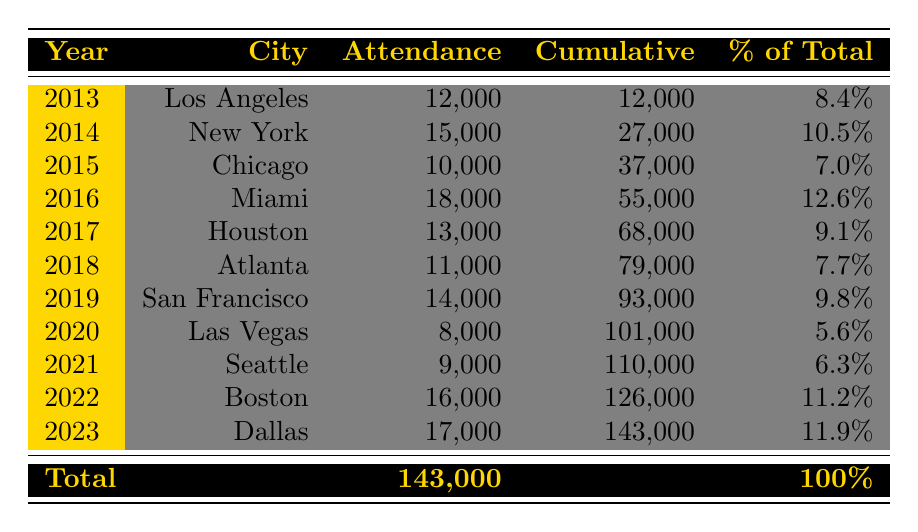What was the attendance at the Miami concert in 2016? The table shows that in 2016, the attendance in Miami was 18,000. This information can be found directly in the table under the Year 2016 and City Miami.
Answer: 18,000 Which city had the highest concert attendance and what was that number? By examining the attendance figures, Miami in 2016 has the highest attendance at 18,000, which is the maximum value compared to others in the table.
Answer: Miami, 18,000 What is the cumulative attendance by the end of 2021? To find the cumulative attendance by the end of 2021, we sum up the attendance values from 2013 to 2021: 12,000 + 15,000 + 10,000 + 18,000 + 13,000 + 11,000 + 14,000 + 8,000 + 9,000 = 110,000. The cumulative value is listed in the table for 2021 under ‘Cumulative’.
Answer: 110,000 Is the percentage of total attendance for Los Angeles in 2013 greater than 10%? Referring to the table, Los Angeles in 2013 has an attendance of 12,000. The total attendance is 143,000, and the percentage for Los Angeles is calculated as (12,000 / 143,000) * 100, which is approximately 8.4%. Since 8.4% is not greater than 10%, the answer is no.
Answer: No What was the difference in attendance between the concerts in Dallas and Chicago? From the table, the attendance in Dallas in 2023 is 17,000 and in Chicago in 2015 is 10,000. To find the difference, we subtract the Chicago attendance from Dallas: 17,000 - 10,000 = 7,000.
Answer: 7,000 What is the average attendance of concerts held between 2014 and 2019? To find the average, we first sum the attendances from 2014 to 2019: 15,000 (New York) + 10,000 (Chicago) + 18,000 (Miami) + 13,000 (Houston) + 11,000 (Atlanta) + 14,000 (San Francisco) = 81,000. There are six values, so we divide: 81,000 / 6 = 13,500.
Answer: 13,500 Which year had the lowest concert attendance and what was that attendance? By reviewing the attendance figures, the lowest is in 2020 with 8,000 at the Las Vegas concert, as identified in the table.
Answer: 2020, 8,000 Did Boston have a concert in 2022, and what was the attendance? Yes, the table lists Boston for the year 2022 with an attendance of 16,000. Therefore, the specific fact is true based on the table data.
Answer: Yes, 16,000 What is the total attendance from concerts performed in Houston and Atlanta combined? The attendance in Houston in 2017 is 13,000, and in Atlanta in 2018 is 11,000. Adding these two values: 13,000 + 11,000 = 24,000 gives us the combined total attendance.
Answer: 24,000 